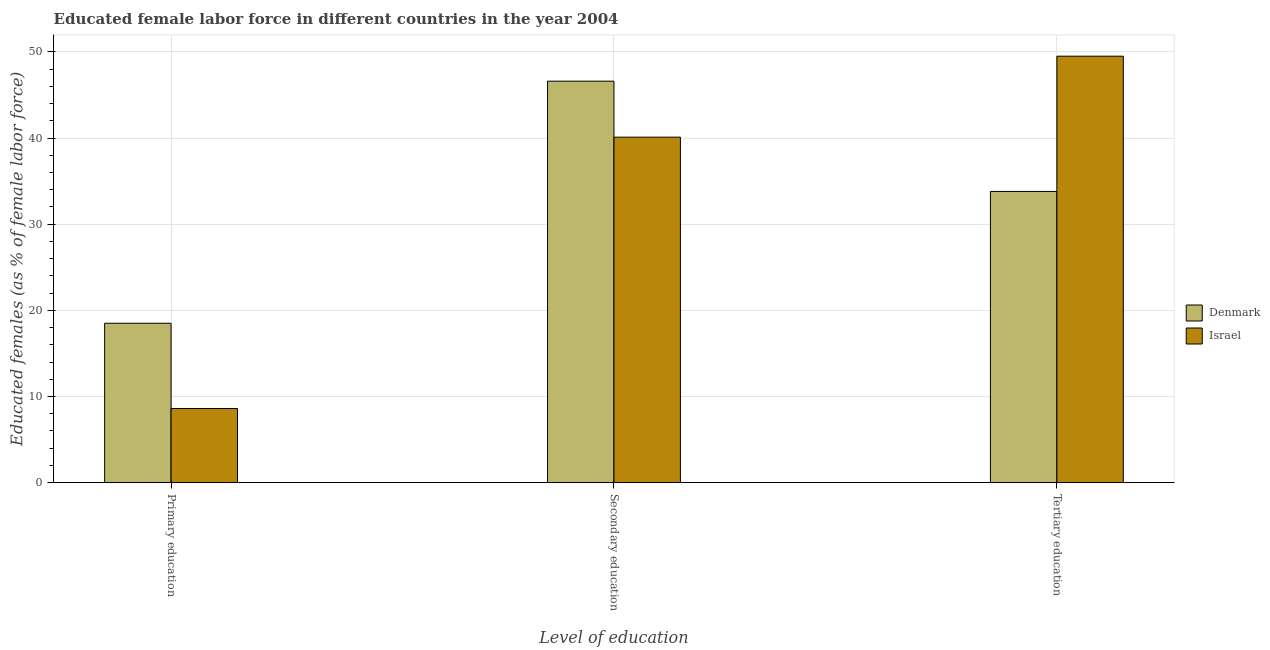Are the number of bars per tick equal to the number of legend labels?
Your response must be concise. Yes. How many bars are there on the 1st tick from the right?
Provide a short and direct response. 2. What is the label of the 2nd group of bars from the left?
Provide a succinct answer. Secondary education. Across all countries, what is the maximum percentage of female labor force who received tertiary education?
Your answer should be compact. 49.5. Across all countries, what is the minimum percentage of female labor force who received tertiary education?
Your response must be concise. 33.8. What is the total percentage of female labor force who received primary education in the graph?
Keep it short and to the point. 27.1. What is the difference between the percentage of female labor force who received tertiary education in Israel and that in Denmark?
Provide a succinct answer. 15.7. What is the difference between the percentage of female labor force who received secondary education in Denmark and the percentage of female labor force who received primary education in Israel?
Your answer should be very brief. 38. What is the average percentage of female labor force who received secondary education per country?
Offer a very short reply. 43.35. What is the difference between the percentage of female labor force who received tertiary education and percentage of female labor force who received primary education in Denmark?
Provide a succinct answer. 15.3. What is the ratio of the percentage of female labor force who received primary education in Denmark to that in Israel?
Your answer should be very brief. 2.15. Is the percentage of female labor force who received primary education in Denmark less than that in Israel?
Your response must be concise. No. Is the difference between the percentage of female labor force who received secondary education in Israel and Denmark greater than the difference between the percentage of female labor force who received primary education in Israel and Denmark?
Provide a succinct answer. Yes. What is the difference between the highest and the second highest percentage of female labor force who received primary education?
Your answer should be compact. 9.9. What is the difference between the highest and the lowest percentage of female labor force who received primary education?
Provide a short and direct response. 9.9. In how many countries, is the percentage of female labor force who received tertiary education greater than the average percentage of female labor force who received tertiary education taken over all countries?
Your answer should be very brief. 1. What does the 1st bar from the left in Tertiary education represents?
Make the answer very short. Denmark. How many bars are there?
Keep it short and to the point. 6. How many countries are there in the graph?
Keep it short and to the point. 2. What is the difference between two consecutive major ticks on the Y-axis?
Offer a very short reply. 10. Does the graph contain any zero values?
Your answer should be compact. No. Does the graph contain grids?
Ensure brevity in your answer.  Yes. Where does the legend appear in the graph?
Offer a terse response. Center right. How many legend labels are there?
Your answer should be very brief. 2. How are the legend labels stacked?
Provide a succinct answer. Vertical. What is the title of the graph?
Provide a short and direct response. Educated female labor force in different countries in the year 2004. What is the label or title of the X-axis?
Your answer should be very brief. Level of education. What is the label or title of the Y-axis?
Make the answer very short. Educated females (as % of female labor force). What is the Educated females (as % of female labor force) in Denmark in Primary education?
Your response must be concise. 18.5. What is the Educated females (as % of female labor force) of Israel in Primary education?
Offer a very short reply. 8.6. What is the Educated females (as % of female labor force) of Denmark in Secondary education?
Give a very brief answer. 46.6. What is the Educated females (as % of female labor force) in Israel in Secondary education?
Your response must be concise. 40.1. What is the Educated females (as % of female labor force) in Denmark in Tertiary education?
Ensure brevity in your answer.  33.8. What is the Educated females (as % of female labor force) in Israel in Tertiary education?
Keep it short and to the point. 49.5. Across all Level of education, what is the maximum Educated females (as % of female labor force) in Denmark?
Your answer should be very brief. 46.6. Across all Level of education, what is the maximum Educated females (as % of female labor force) in Israel?
Provide a short and direct response. 49.5. Across all Level of education, what is the minimum Educated females (as % of female labor force) of Israel?
Give a very brief answer. 8.6. What is the total Educated females (as % of female labor force) in Denmark in the graph?
Ensure brevity in your answer.  98.9. What is the total Educated females (as % of female labor force) in Israel in the graph?
Provide a succinct answer. 98.2. What is the difference between the Educated females (as % of female labor force) of Denmark in Primary education and that in Secondary education?
Make the answer very short. -28.1. What is the difference between the Educated females (as % of female labor force) in Israel in Primary education and that in Secondary education?
Your answer should be very brief. -31.5. What is the difference between the Educated females (as % of female labor force) of Denmark in Primary education and that in Tertiary education?
Ensure brevity in your answer.  -15.3. What is the difference between the Educated females (as % of female labor force) in Israel in Primary education and that in Tertiary education?
Offer a very short reply. -40.9. What is the difference between the Educated females (as % of female labor force) of Denmark in Primary education and the Educated females (as % of female labor force) of Israel in Secondary education?
Provide a short and direct response. -21.6. What is the difference between the Educated females (as % of female labor force) in Denmark in Primary education and the Educated females (as % of female labor force) in Israel in Tertiary education?
Keep it short and to the point. -31. What is the difference between the Educated females (as % of female labor force) in Denmark in Secondary education and the Educated females (as % of female labor force) in Israel in Tertiary education?
Provide a short and direct response. -2.9. What is the average Educated females (as % of female labor force) of Denmark per Level of education?
Provide a succinct answer. 32.97. What is the average Educated females (as % of female labor force) of Israel per Level of education?
Give a very brief answer. 32.73. What is the difference between the Educated females (as % of female labor force) of Denmark and Educated females (as % of female labor force) of Israel in Secondary education?
Provide a succinct answer. 6.5. What is the difference between the Educated females (as % of female labor force) in Denmark and Educated females (as % of female labor force) in Israel in Tertiary education?
Ensure brevity in your answer.  -15.7. What is the ratio of the Educated females (as % of female labor force) in Denmark in Primary education to that in Secondary education?
Offer a terse response. 0.4. What is the ratio of the Educated females (as % of female labor force) in Israel in Primary education to that in Secondary education?
Offer a very short reply. 0.21. What is the ratio of the Educated females (as % of female labor force) in Denmark in Primary education to that in Tertiary education?
Provide a succinct answer. 0.55. What is the ratio of the Educated females (as % of female labor force) in Israel in Primary education to that in Tertiary education?
Offer a very short reply. 0.17. What is the ratio of the Educated females (as % of female labor force) of Denmark in Secondary education to that in Tertiary education?
Provide a succinct answer. 1.38. What is the ratio of the Educated females (as % of female labor force) of Israel in Secondary education to that in Tertiary education?
Offer a terse response. 0.81. What is the difference between the highest and the second highest Educated females (as % of female labor force) of Israel?
Ensure brevity in your answer.  9.4. What is the difference between the highest and the lowest Educated females (as % of female labor force) of Denmark?
Your answer should be very brief. 28.1. What is the difference between the highest and the lowest Educated females (as % of female labor force) of Israel?
Your answer should be compact. 40.9. 